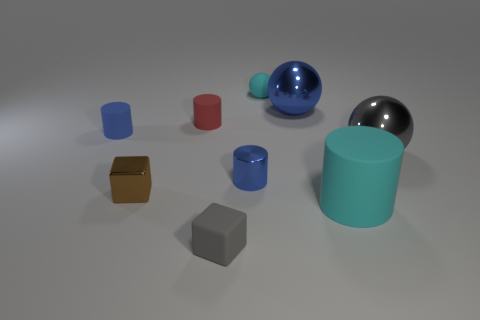Is the small sphere the same color as the large cylinder?
Make the answer very short. Yes. What number of tiny things are either shiny cubes or red rubber spheres?
Ensure brevity in your answer.  1. Are there any other things that have the same color as the small shiny block?
Provide a short and direct response. No. There is a large cyan object that is made of the same material as the tiny ball; what shape is it?
Give a very brief answer. Cylinder. What is the size of the thing that is in front of the cyan cylinder?
Make the answer very short. Small. The gray rubber object is what shape?
Give a very brief answer. Cube. Does the gray thing behind the tiny gray block have the same size as the cyan object behind the large cylinder?
Give a very brief answer. No. What size is the cyan object left of the large object that is in front of the big shiny sphere that is in front of the blue rubber cylinder?
Your answer should be compact. Small. There is a blue metallic object that is in front of the blue thing to the left of the blue shiny thing that is on the left side of the tiny cyan sphere; what shape is it?
Your response must be concise. Cylinder. The small thing that is behind the large blue object has what shape?
Make the answer very short. Sphere. 